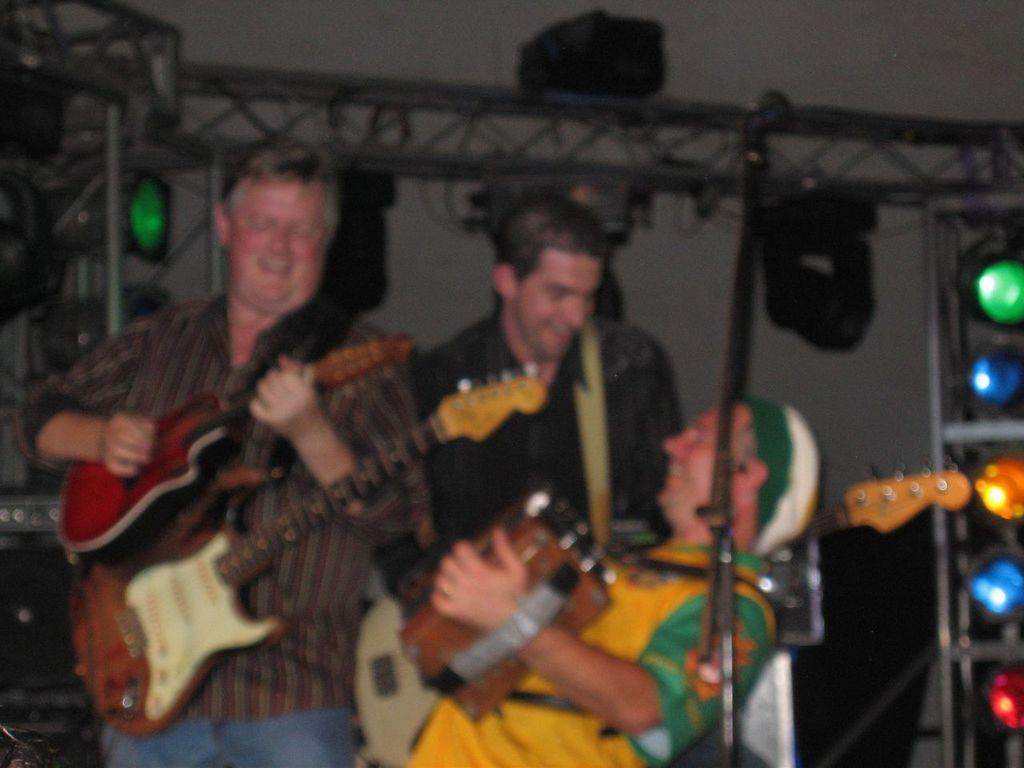How many people are in the image? There are three persons in the image. What are the persons doing in the image? The persons are playing guitar. What can be seen in the background of the image? There is a wall in the background of the image. What else is visible in the image besides the persons and the wall? There are lights visible in the image. What type of fold can be seen in the image? There is no fold present in the image. How many corks are visible in the image? There are no corks present in the image. 